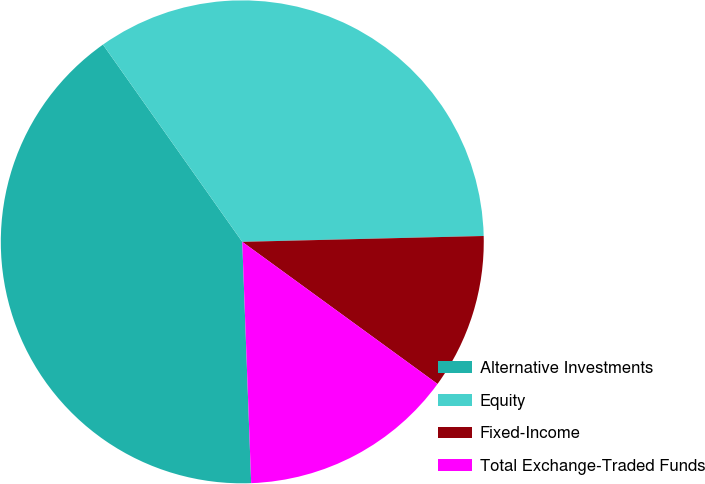<chart> <loc_0><loc_0><loc_500><loc_500><pie_chart><fcel>Alternative Investments<fcel>Equity<fcel>Fixed-Income<fcel>Total Exchange-Traded Funds<nl><fcel>40.8%<fcel>34.4%<fcel>10.4%<fcel>14.4%<nl></chart> 